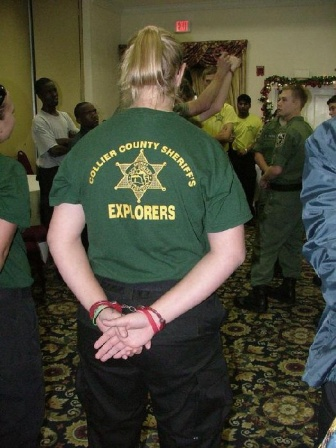Analyze the image in a comprehensive and detailed manner. The image depicts a gathering of individuals, possibly at a community or organization event. The focal point is a person seen from the back, wearing a green t-shirt with the text "Collier County Sheriff's Explorers" accompanied by a logo. The uniform suggests affiliation with a youth or volunteer program associated with the Collier County Sheriff's Office. Around this person, several other individuals are also wearing the sharegpt4v/same green t-shirts, implying they are members of this group. Additionally, there are individuals in gray uniforms, suggesting some attendees might be official personnel, possibly sheriffs or other members of law enforcement. The room's festive decoration, such as the garland and ornaments visible on the walls, indicates the event might be a holiday celebration, likely around Christmas. The indoor setting is corroborated by the visible door and the patterned carpet. Overall, the scene captures a communal moment among the Collier County Sheriff's Explorers during a celebratory or formal event. 